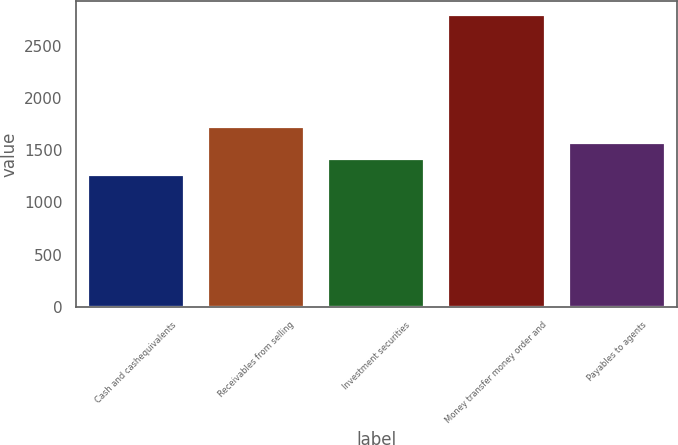Convert chart to OTSL. <chart><loc_0><loc_0><loc_500><loc_500><bar_chart><fcel>Cash and cashequivalents<fcel>Receivables from selling<fcel>Investment securities<fcel>Money transfer money order and<fcel>Payables to agents<nl><fcel>1264.8<fcel>1722.12<fcel>1417.24<fcel>2789.2<fcel>1569.68<nl></chart> 